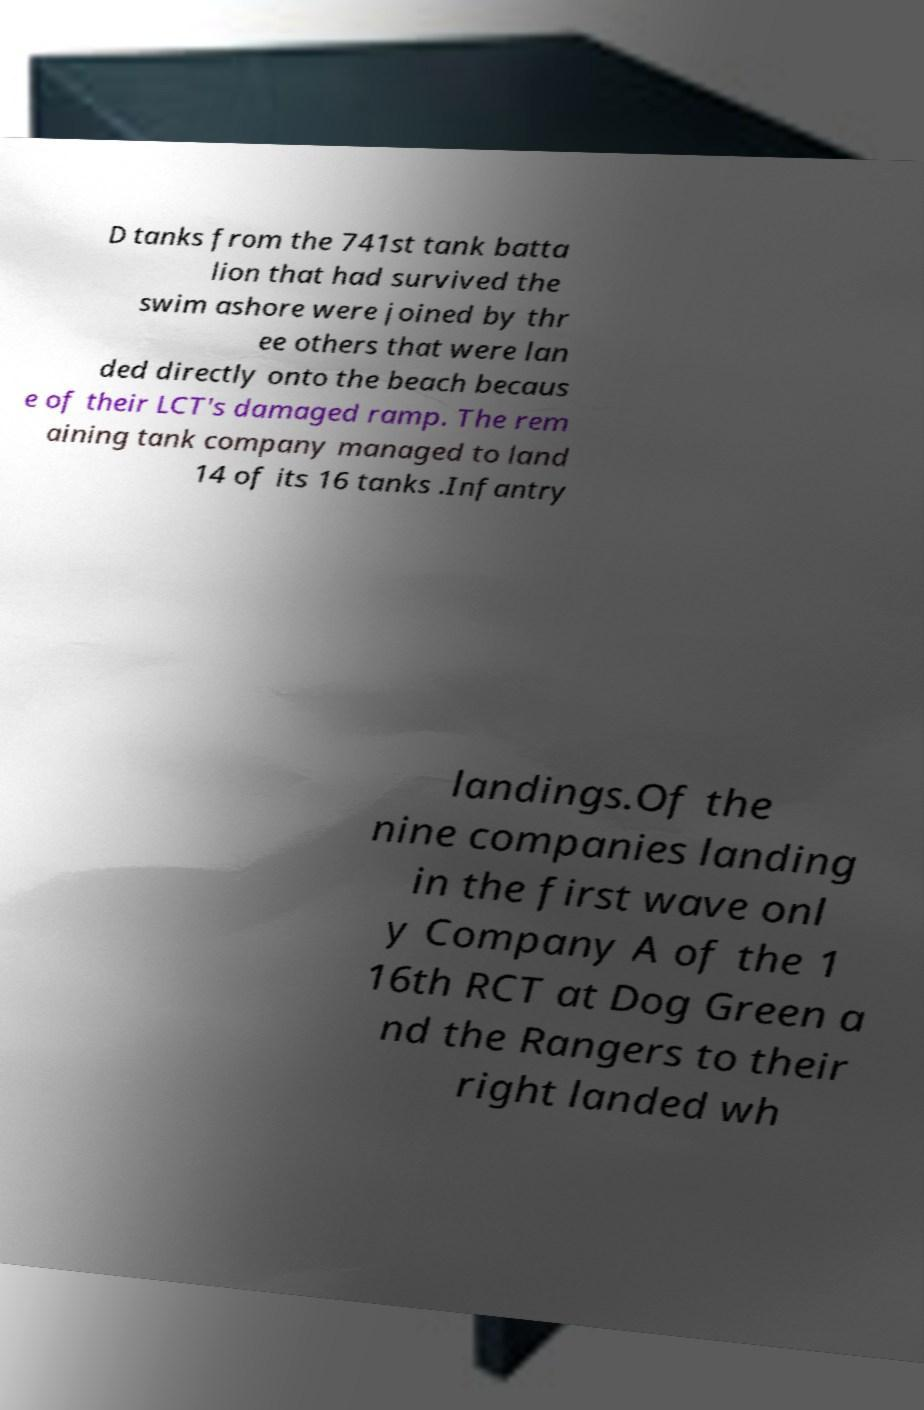Could you assist in decoding the text presented in this image and type it out clearly? D tanks from the 741st tank batta lion that had survived the swim ashore were joined by thr ee others that were lan ded directly onto the beach becaus e of their LCT's damaged ramp. The rem aining tank company managed to land 14 of its 16 tanks .Infantry landings.Of the nine companies landing in the first wave onl y Company A of the 1 16th RCT at Dog Green a nd the Rangers to their right landed wh 